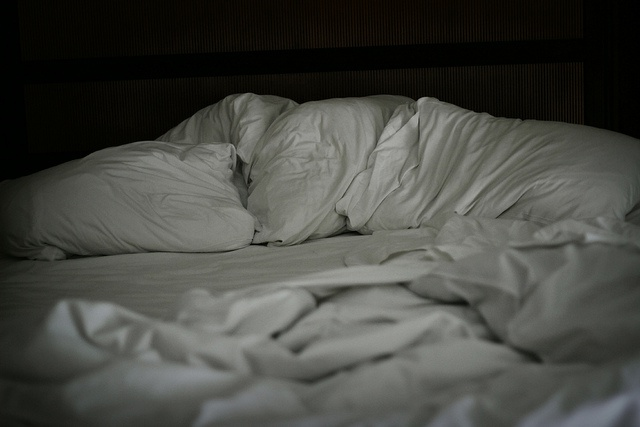Describe the objects in this image and their specific colors. I can see a bed in gray and black tones in this image. 